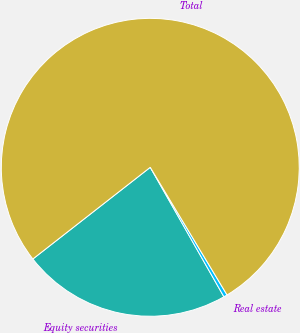Convert chart. <chart><loc_0><loc_0><loc_500><loc_500><pie_chart><fcel>Equity securities<fcel>Real estate<fcel>Total<nl><fcel>22.68%<fcel>0.39%<fcel>76.93%<nl></chart> 